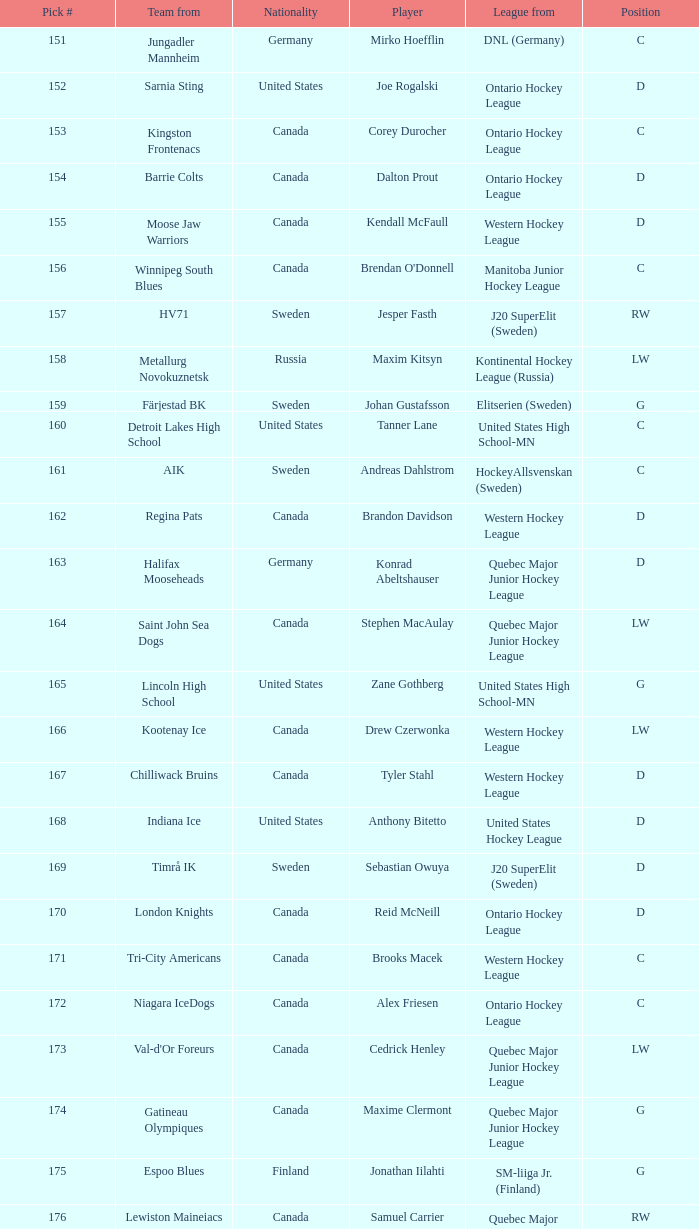What is the average pick # from the Quebec Major Junior Hockey League player Samuel Carrier? 176.0. 